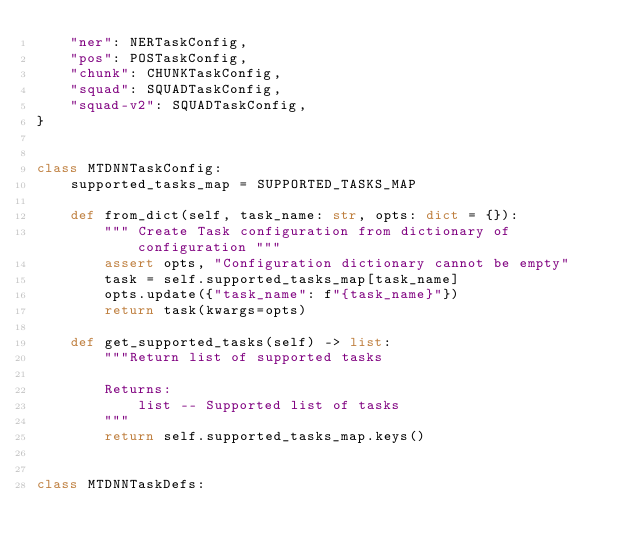Convert code to text. <code><loc_0><loc_0><loc_500><loc_500><_Python_>    "ner": NERTaskConfig,
    "pos": POSTaskConfig,
    "chunk": CHUNKTaskConfig,
    "squad": SQUADTaskConfig,
    "squad-v2": SQUADTaskConfig,
}


class MTDNNTaskConfig:
    supported_tasks_map = SUPPORTED_TASKS_MAP

    def from_dict(self, task_name: str, opts: dict = {}):
        """ Create Task configuration from dictionary of configuration """
        assert opts, "Configuration dictionary cannot be empty"
        task = self.supported_tasks_map[task_name]
        opts.update({"task_name": f"{task_name}"})
        return task(kwargs=opts)

    def get_supported_tasks(self) -> list:
        """Return list of supported tasks

        Returns:
            list -- Supported list of tasks
        """
        return self.supported_tasks_map.keys()


class MTDNNTaskDefs:</code> 